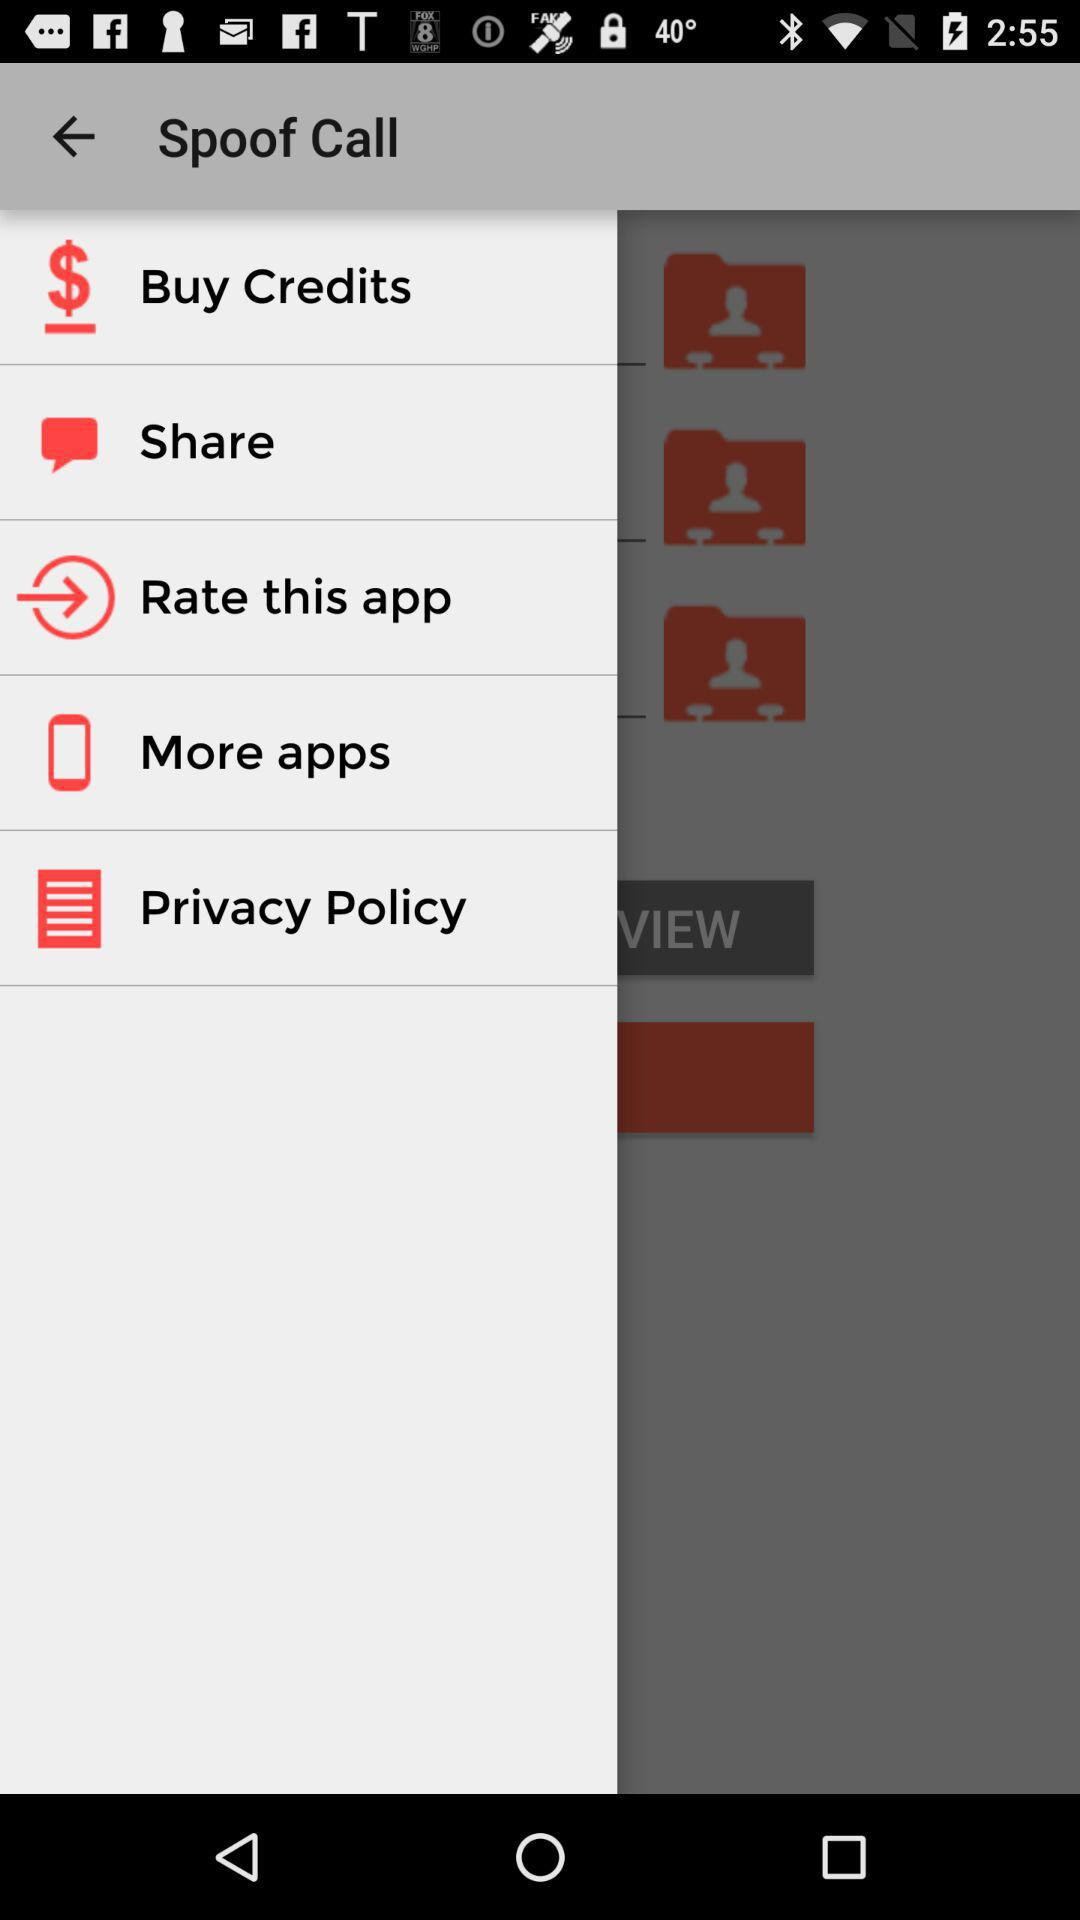What is the name of the application? The name of the application is "Spoof Call". 